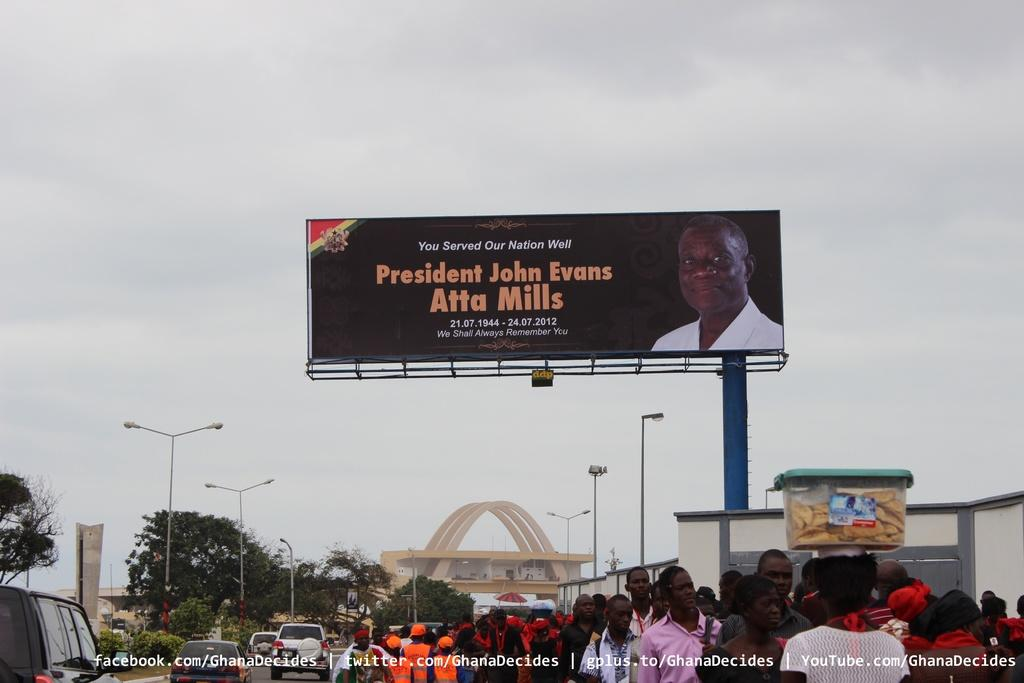<image>
Present a compact description of the photo's key features. A billboard recognizes the death of a former president. 